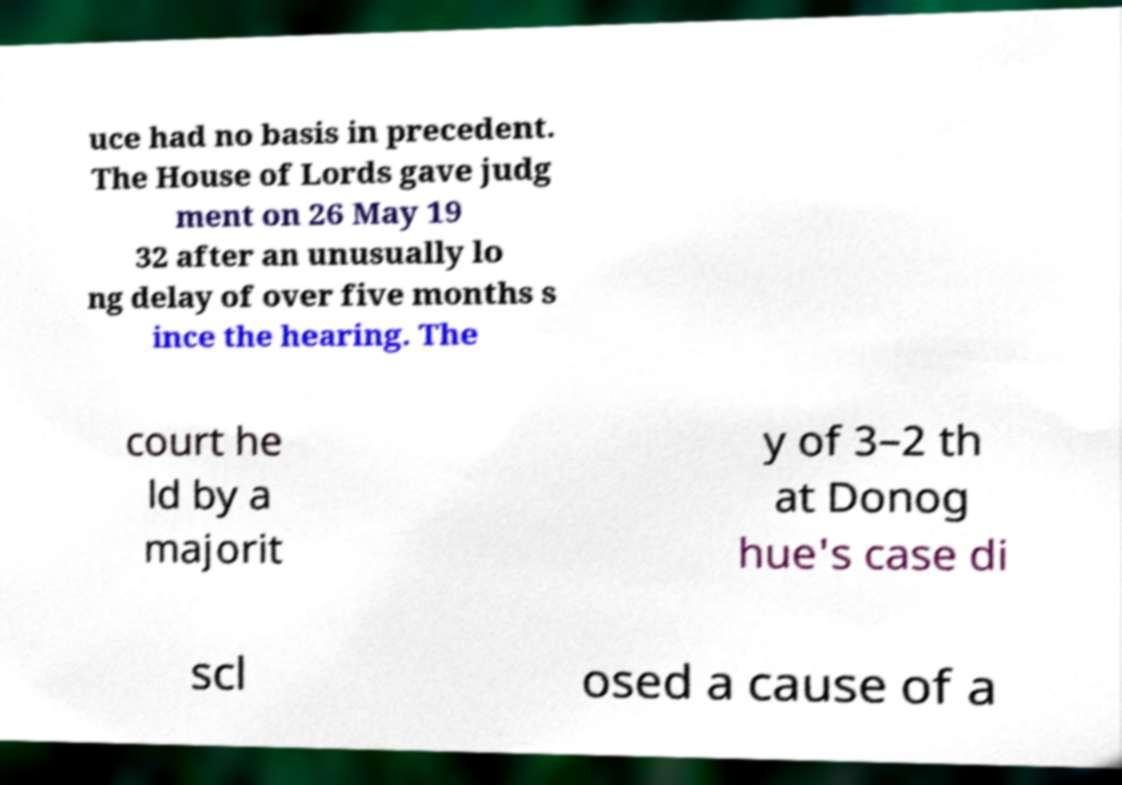Please identify and transcribe the text found in this image. uce had no basis in precedent. The House of Lords gave judg ment on 26 May 19 32 after an unusually lo ng delay of over five months s ince the hearing. The court he ld by a majorit y of 3–2 th at Donog hue's case di scl osed a cause of a 